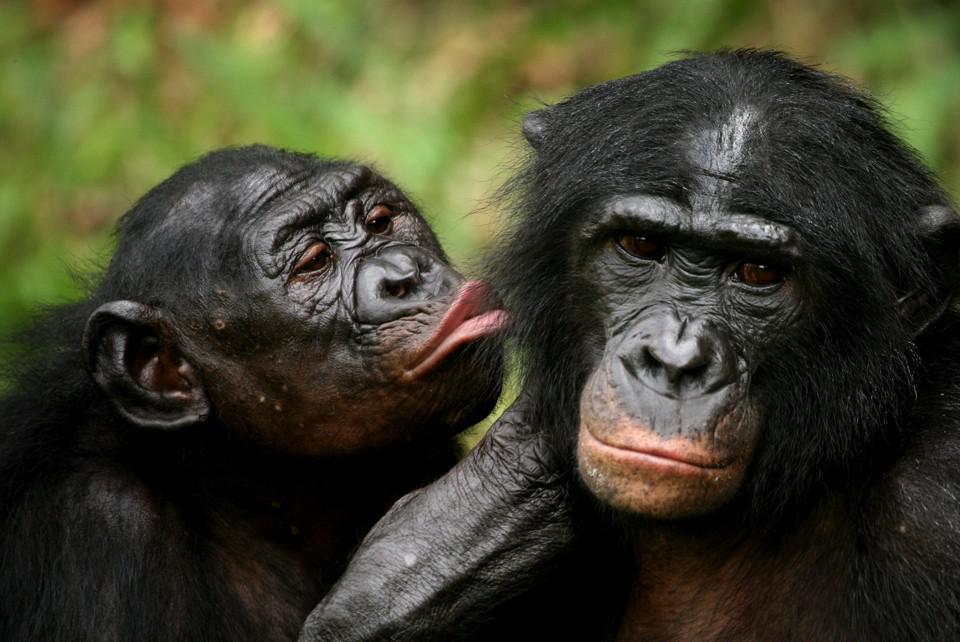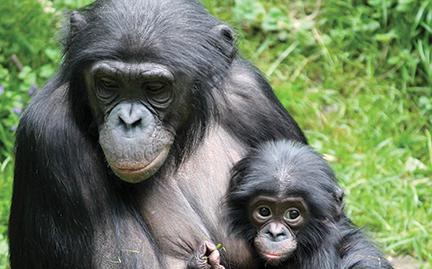The first image is the image on the left, the second image is the image on the right. Considering the images on both sides, is "there is a mother chimp holding her infant" valid? Answer yes or no. Yes. The first image is the image on the left, the second image is the image on the right. Examine the images to the left and right. Is the description "At least one of the monkeys is a baby." accurate? Answer yes or no. Yes. 